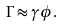Convert formula to latex. <formula><loc_0><loc_0><loc_500><loc_500>\Gamma \approx \gamma \phi .</formula> 